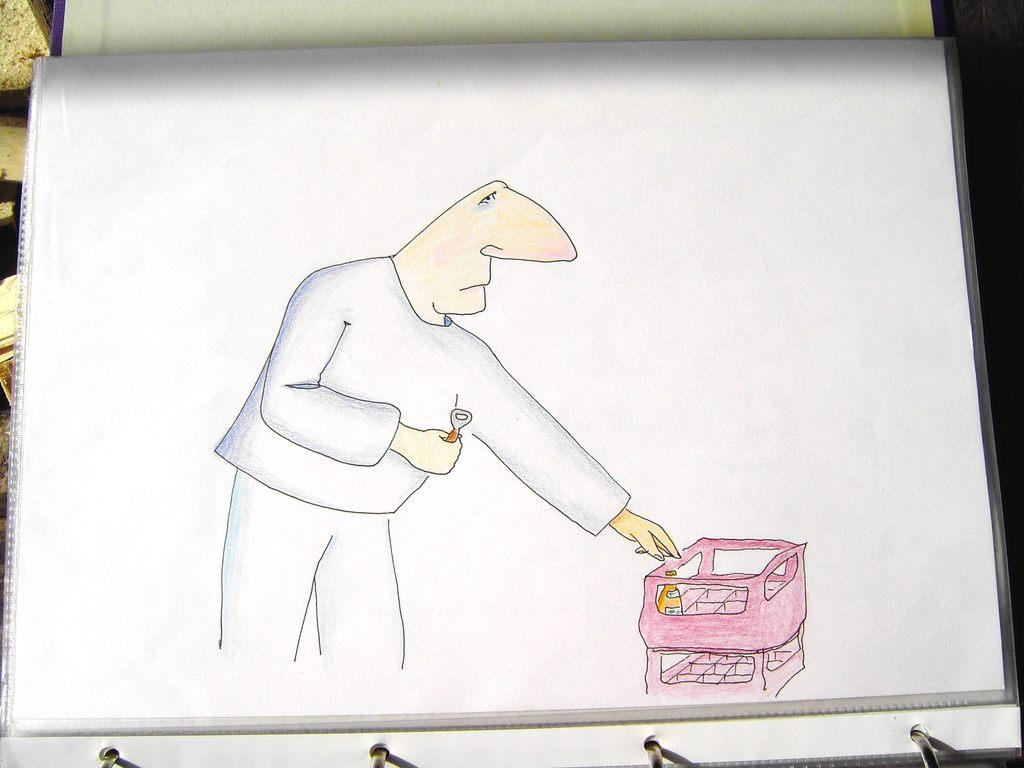What is on the paper in the image? There is a drawing on the paper. What does the drawing depict? The drawing depicts a man standing. What can be seen in the image besides the drawing? There is a basket in the image. What is the color of the basket? The basket is pink in color. What is inside the basket? There is an object in the basket. What type of cent is present in the image? There are no cents present in the image. 